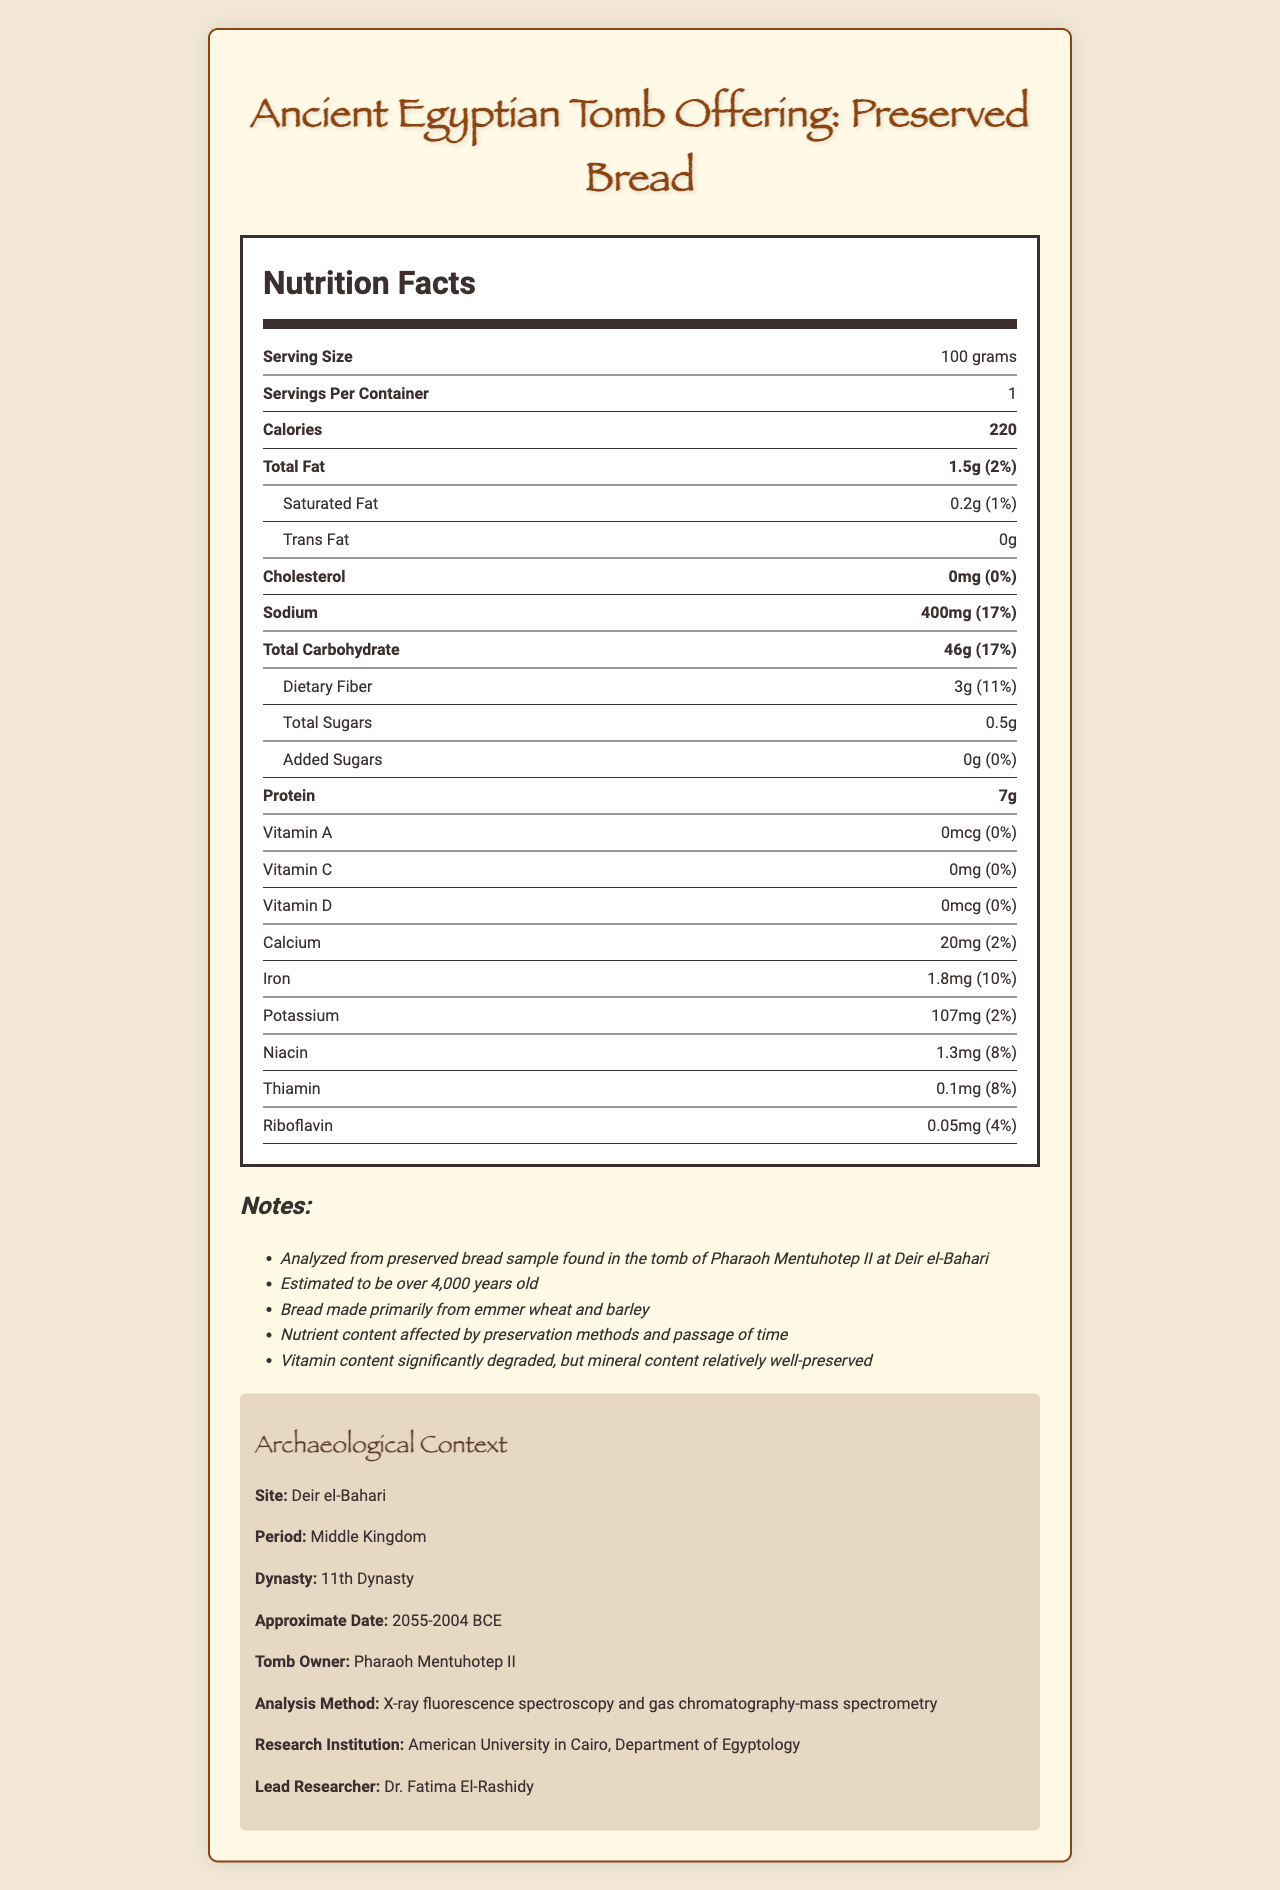What is the serving size of the preserved bread? The document clearly states the serving size as 100 grams.
Answer: 100 grams How many calories are in one serving of the preserved bread? The nutrition label indicates that there are 220 calories per serving.
Answer: 220 What is the total fat content in one serving of the bread? The total fat content listed in the document is 1.5 grams.
Answer: 1.5 grams Is there any cholesterol in the preserved bread? The cholesterol amount listed in the nutrition facts is 0 mg.
Answer: No What is the daily value percentage for sodium in one serving of the bread? The document shows that the daily value percentage for sodium is 17%.
Answer: 17% How much dietary fiber does one serving of this bread contain? The document lists the dietary fiber content as 3 grams.
Answer: 3 grams Which grain is primarily used to make the bread? A. Wheat B. Emmer wheat C. Barley D. Oats The notes mention that the bread is made primarily from emmer wheat and barley, with emmer wheat listed first.
Answer: B. Emmer wheat Which of the following vitamins is not present in the preserved bread? A. Vitamin A B. Vitamin C C. Vitamin D D. Vitamin E The document lists Vitamin A, Vitamin C, and Vitamin D, but does not mention Vitamin E.
Answer: D. Vitamin E Is the iron content well-preserved in the bread? Yes/No The notes section indicates that the mineral content is relatively well-preserved, which would include iron.
Answer: Yes Summarize the main idea of the document. This summary encapsulates the key aspects: the nutrient analysis, the origin of the bread, and its historical context.
Answer: The document provides a detailed nutrient analysis of a preserved bread sample found in the tomb of Pharaoh Mentuhotep II, including its vitamin and mineral content, the serving size, and the archaeological context of the find. Where can you find information about modern preservation methods used on the bread? The document does not provide any details about modern preservation methods.
Answer: Not enough information 